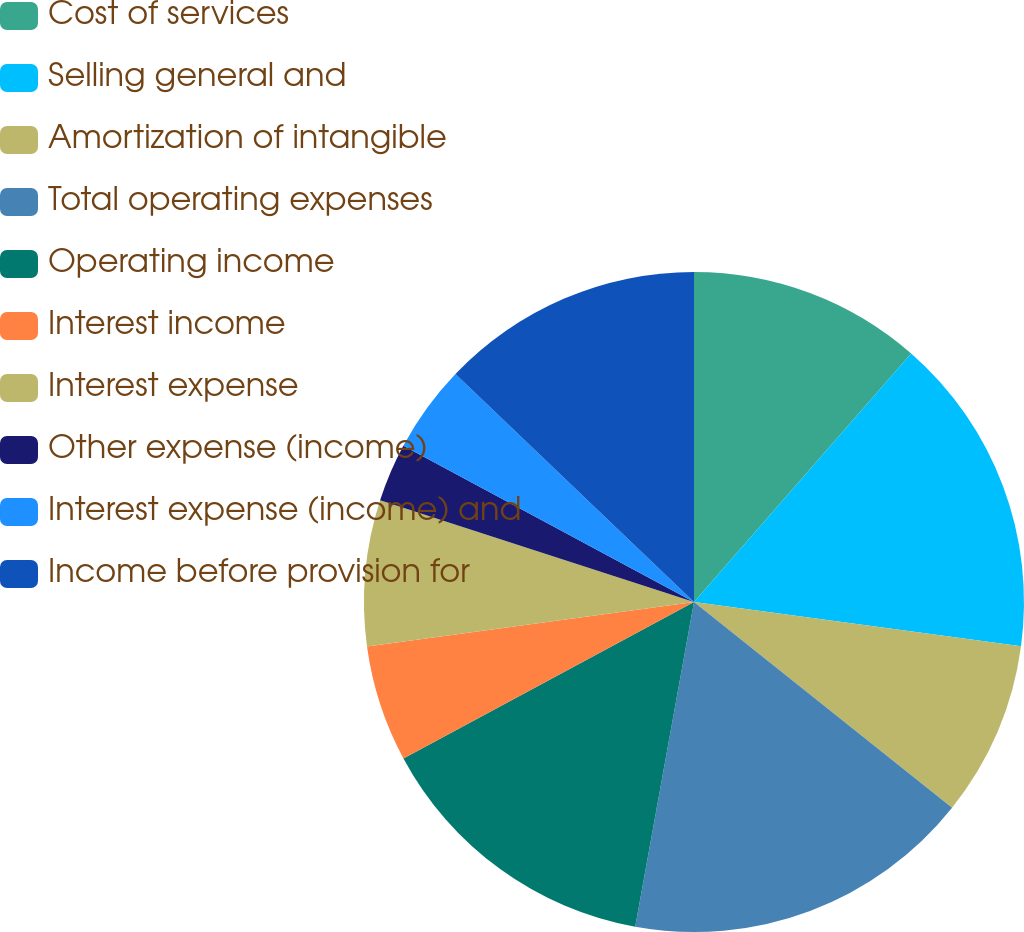Convert chart. <chart><loc_0><loc_0><loc_500><loc_500><pie_chart><fcel>Cost of services<fcel>Selling general and<fcel>Amortization of intangible<fcel>Total operating expenses<fcel>Operating income<fcel>Interest income<fcel>Interest expense<fcel>Other expense (income)<fcel>Interest expense (income) and<fcel>Income before provision for<nl><fcel>11.43%<fcel>15.71%<fcel>8.57%<fcel>17.14%<fcel>14.29%<fcel>5.71%<fcel>7.14%<fcel>2.86%<fcel>4.29%<fcel>12.86%<nl></chart> 